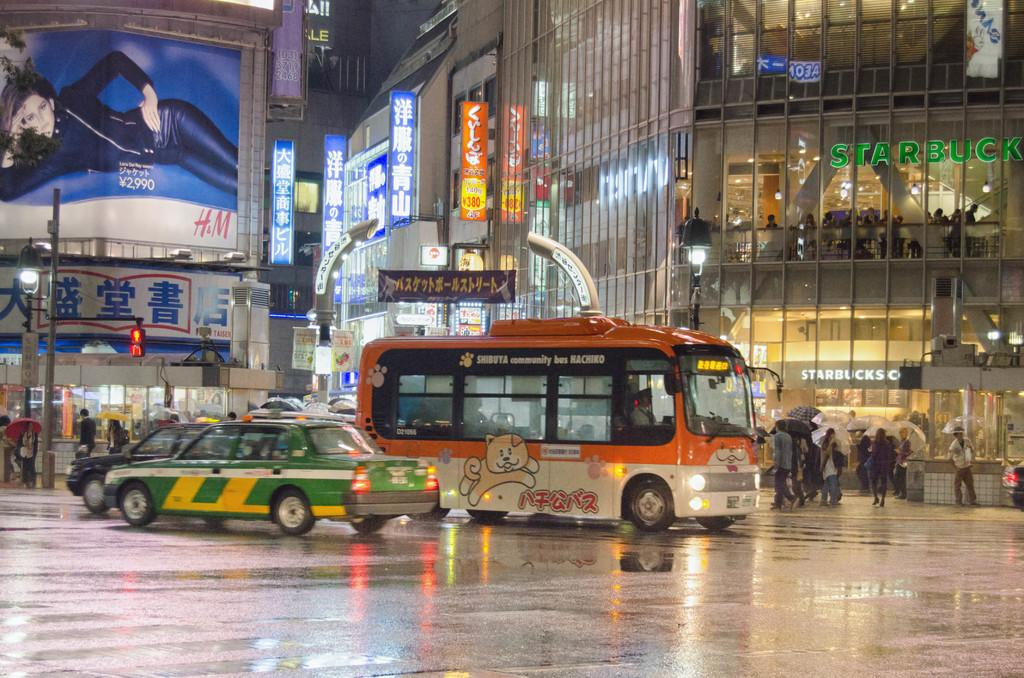<image>
Relay a brief, clear account of the picture shown. A green taxi and and orange bus are on a busy street in the rain in front of a large Starbucks. 